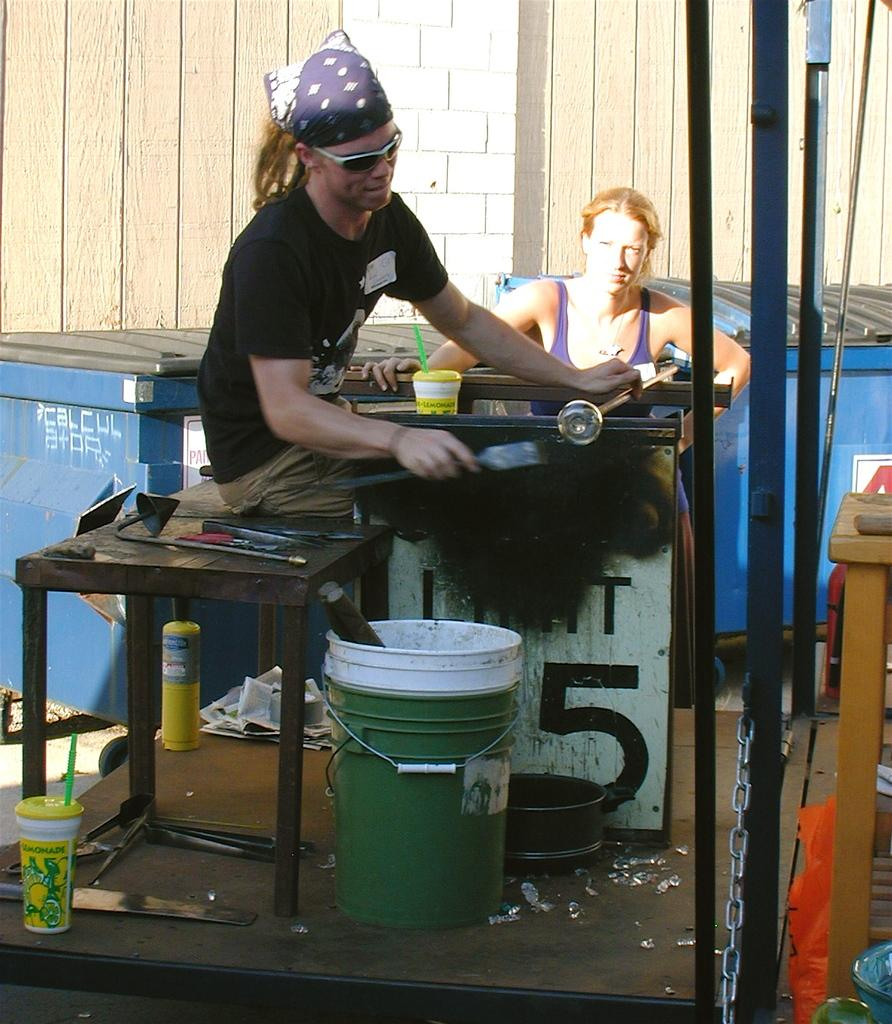Who is the person in the image? There is a man in the image. What is the man wearing? The man is wearing a black t-shirt. What is the man doing in the image? The man is sitting on a table and doing some work. What can be seen in the background of the image? There is a wall in the background of the image. What type of beef is the man eating in the image? There is no beef present in the image; the man is doing some work while sitting on a table. 